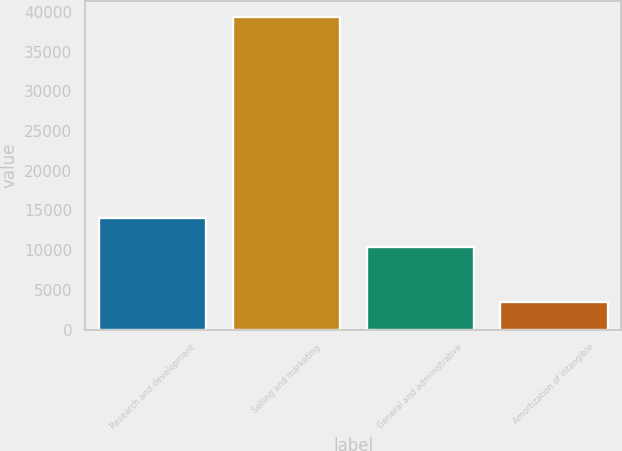Convert chart to OTSL. <chart><loc_0><loc_0><loc_500><loc_500><bar_chart><fcel>Research and development<fcel>Selling and marketing<fcel>General and administrative<fcel>Amortization of intangible<nl><fcel>14041<fcel>39356<fcel>10453<fcel>3476<nl></chart> 